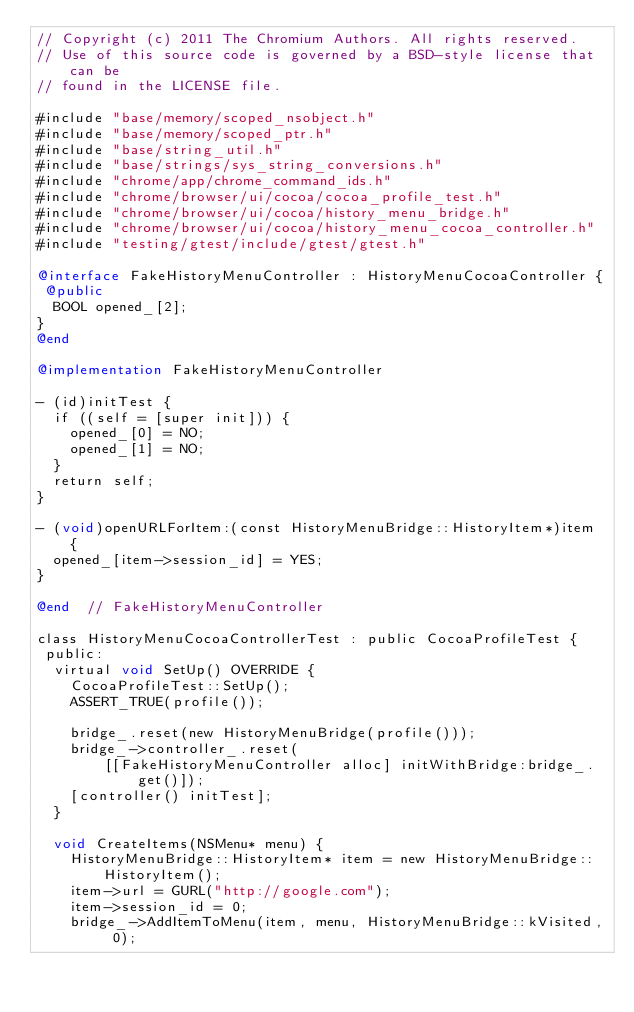<code> <loc_0><loc_0><loc_500><loc_500><_ObjectiveC_>// Copyright (c) 2011 The Chromium Authors. All rights reserved.
// Use of this source code is governed by a BSD-style license that can be
// found in the LICENSE file.

#include "base/memory/scoped_nsobject.h"
#include "base/memory/scoped_ptr.h"
#include "base/string_util.h"
#include "base/strings/sys_string_conversions.h"
#include "chrome/app/chrome_command_ids.h"
#include "chrome/browser/ui/cocoa/cocoa_profile_test.h"
#include "chrome/browser/ui/cocoa/history_menu_bridge.h"
#include "chrome/browser/ui/cocoa/history_menu_cocoa_controller.h"
#include "testing/gtest/include/gtest/gtest.h"

@interface FakeHistoryMenuController : HistoryMenuCocoaController {
 @public
  BOOL opened_[2];
}
@end

@implementation FakeHistoryMenuController

- (id)initTest {
  if ((self = [super init])) {
    opened_[0] = NO;
    opened_[1] = NO;
  }
  return self;
}

- (void)openURLForItem:(const HistoryMenuBridge::HistoryItem*)item {
  opened_[item->session_id] = YES;
}

@end  // FakeHistoryMenuController

class HistoryMenuCocoaControllerTest : public CocoaProfileTest {
 public:
  virtual void SetUp() OVERRIDE {
    CocoaProfileTest::SetUp();
    ASSERT_TRUE(profile());

    bridge_.reset(new HistoryMenuBridge(profile()));
    bridge_->controller_.reset(
        [[FakeHistoryMenuController alloc] initWithBridge:bridge_.get()]);
    [controller() initTest];
  }

  void CreateItems(NSMenu* menu) {
    HistoryMenuBridge::HistoryItem* item = new HistoryMenuBridge::HistoryItem();
    item->url = GURL("http://google.com");
    item->session_id = 0;
    bridge_->AddItemToMenu(item, menu, HistoryMenuBridge::kVisited, 0);
</code> 